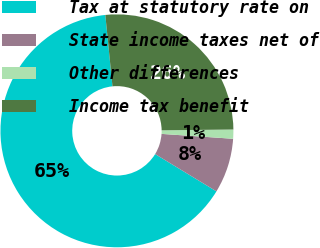Convert chart. <chart><loc_0><loc_0><loc_500><loc_500><pie_chart><fcel>Tax at statutory rate on<fcel>State income taxes net of<fcel>Other differences<fcel>Income tax benefit<nl><fcel>64.72%<fcel>7.61%<fcel>1.27%<fcel>26.41%<nl></chart> 